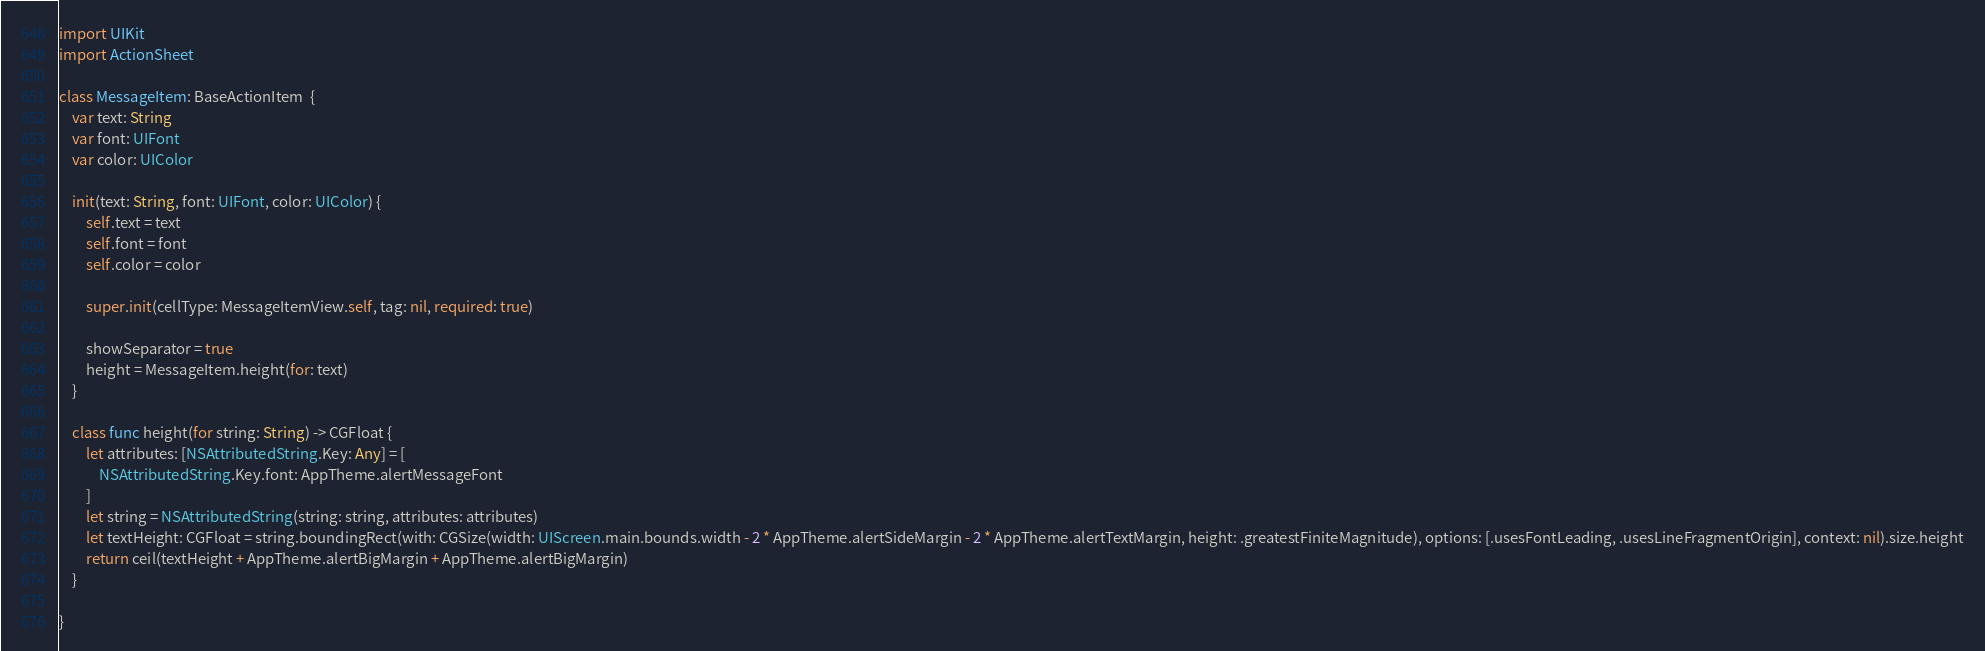<code> <loc_0><loc_0><loc_500><loc_500><_Swift_>import UIKit
import ActionSheet

class MessageItem: BaseActionItem  {
    var text: String
    var font: UIFont
    var color: UIColor

    init(text: String, font: UIFont, color: UIColor) {
        self.text = text
        self.font = font
        self.color = color

        super.init(cellType: MessageItemView.self, tag: nil, required: true)

        showSeparator = true
        height = MessageItem.height(for: text)
    }

    class func height(for string: String) -> CGFloat {
        let attributes: [NSAttributedString.Key: Any] = [
            NSAttributedString.Key.font: AppTheme.alertMessageFont
        ]
        let string = NSAttributedString(string: string, attributes: attributes)
        let textHeight: CGFloat = string.boundingRect(with: CGSize(width: UIScreen.main.bounds.width - 2 * AppTheme.alertSideMargin - 2 * AppTheme.alertTextMargin, height: .greatestFiniteMagnitude), options: [.usesFontLeading, .usesLineFragmentOrigin], context: nil).size.height
        return ceil(textHeight + AppTheme.alertBigMargin + AppTheme.alertBigMargin)
    }

}
</code> 